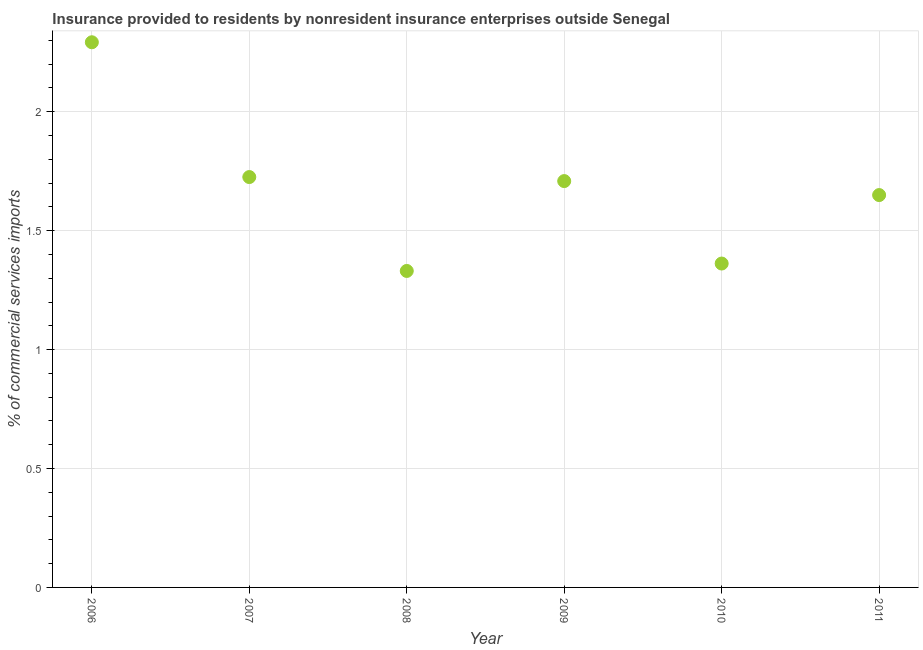What is the insurance provided by non-residents in 2006?
Make the answer very short. 2.29. Across all years, what is the maximum insurance provided by non-residents?
Keep it short and to the point. 2.29. Across all years, what is the minimum insurance provided by non-residents?
Provide a succinct answer. 1.33. What is the sum of the insurance provided by non-residents?
Provide a succinct answer. 10.07. What is the difference between the insurance provided by non-residents in 2007 and 2009?
Provide a short and direct response. 0.02. What is the average insurance provided by non-residents per year?
Offer a terse response. 1.68. What is the median insurance provided by non-residents?
Give a very brief answer. 1.68. Do a majority of the years between 2009 and 2011 (inclusive) have insurance provided by non-residents greater than 1.2 %?
Offer a terse response. Yes. What is the ratio of the insurance provided by non-residents in 2007 to that in 2010?
Offer a terse response. 1.27. Is the insurance provided by non-residents in 2007 less than that in 2010?
Provide a succinct answer. No. Is the difference between the insurance provided by non-residents in 2006 and 2009 greater than the difference between any two years?
Provide a succinct answer. No. What is the difference between the highest and the second highest insurance provided by non-residents?
Ensure brevity in your answer.  0.57. Is the sum of the insurance provided by non-residents in 2008 and 2011 greater than the maximum insurance provided by non-residents across all years?
Make the answer very short. Yes. What is the difference between the highest and the lowest insurance provided by non-residents?
Provide a succinct answer. 0.96. In how many years, is the insurance provided by non-residents greater than the average insurance provided by non-residents taken over all years?
Offer a very short reply. 3. How many dotlines are there?
Your response must be concise. 1. What is the difference between two consecutive major ticks on the Y-axis?
Make the answer very short. 0.5. Are the values on the major ticks of Y-axis written in scientific E-notation?
Your answer should be very brief. No. Does the graph contain any zero values?
Ensure brevity in your answer.  No. Does the graph contain grids?
Your answer should be very brief. Yes. What is the title of the graph?
Ensure brevity in your answer.  Insurance provided to residents by nonresident insurance enterprises outside Senegal. What is the label or title of the Y-axis?
Make the answer very short. % of commercial services imports. What is the % of commercial services imports in 2006?
Your response must be concise. 2.29. What is the % of commercial services imports in 2007?
Ensure brevity in your answer.  1.73. What is the % of commercial services imports in 2008?
Offer a terse response. 1.33. What is the % of commercial services imports in 2009?
Your answer should be very brief. 1.71. What is the % of commercial services imports in 2010?
Keep it short and to the point. 1.36. What is the % of commercial services imports in 2011?
Keep it short and to the point. 1.65. What is the difference between the % of commercial services imports in 2006 and 2007?
Your answer should be very brief. 0.57. What is the difference between the % of commercial services imports in 2006 and 2008?
Make the answer very short. 0.96. What is the difference between the % of commercial services imports in 2006 and 2009?
Ensure brevity in your answer.  0.58. What is the difference between the % of commercial services imports in 2006 and 2010?
Offer a very short reply. 0.93. What is the difference between the % of commercial services imports in 2006 and 2011?
Your response must be concise. 0.64. What is the difference between the % of commercial services imports in 2007 and 2008?
Your response must be concise. 0.39. What is the difference between the % of commercial services imports in 2007 and 2009?
Provide a short and direct response. 0.02. What is the difference between the % of commercial services imports in 2007 and 2010?
Ensure brevity in your answer.  0.36. What is the difference between the % of commercial services imports in 2007 and 2011?
Provide a short and direct response. 0.08. What is the difference between the % of commercial services imports in 2008 and 2009?
Offer a terse response. -0.38. What is the difference between the % of commercial services imports in 2008 and 2010?
Your answer should be compact. -0.03. What is the difference between the % of commercial services imports in 2008 and 2011?
Make the answer very short. -0.32. What is the difference between the % of commercial services imports in 2009 and 2010?
Provide a short and direct response. 0.35. What is the difference between the % of commercial services imports in 2009 and 2011?
Offer a very short reply. 0.06. What is the difference between the % of commercial services imports in 2010 and 2011?
Give a very brief answer. -0.29. What is the ratio of the % of commercial services imports in 2006 to that in 2007?
Ensure brevity in your answer.  1.33. What is the ratio of the % of commercial services imports in 2006 to that in 2008?
Provide a succinct answer. 1.72. What is the ratio of the % of commercial services imports in 2006 to that in 2009?
Provide a short and direct response. 1.34. What is the ratio of the % of commercial services imports in 2006 to that in 2010?
Keep it short and to the point. 1.68. What is the ratio of the % of commercial services imports in 2006 to that in 2011?
Provide a succinct answer. 1.39. What is the ratio of the % of commercial services imports in 2007 to that in 2008?
Your answer should be compact. 1.3. What is the ratio of the % of commercial services imports in 2007 to that in 2009?
Offer a very short reply. 1.01. What is the ratio of the % of commercial services imports in 2007 to that in 2010?
Your response must be concise. 1.27. What is the ratio of the % of commercial services imports in 2007 to that in 2011?
Give a very brief answer. 1.05. What is the ratio of the % of commercial services imports in 2008 to that in 2009?
Provide a succinct answer. 0.78. What is the ratio of the % of commercial services imports in 2008 to that in 2011?
Provide a short and direct response. 0.81. What is the ratio of the % of commercial services imports in 2009 to that in 2010?
Keep it short and to the point. 1.25. What is the ratio of the % of commercial services imports in 2009 to that in 2011?
Your answer should be compact. 1.04. What is the ratio of the % of commercial services imports in 2010 to that in 2011?
Give a very brief answer. 0.82. 